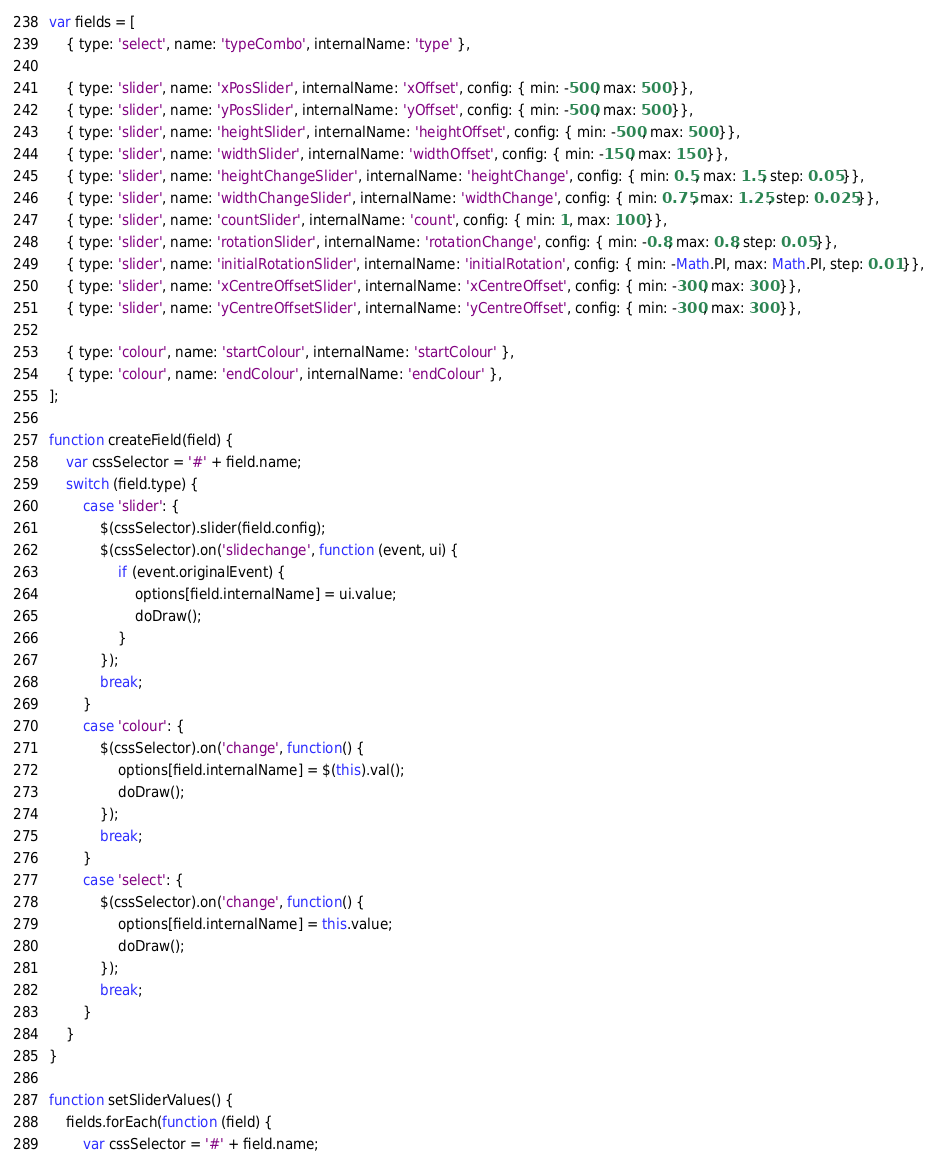Convert code to text. <code><loc_0><loc_0><loc_500><loc_500><_JavaScript_>var fields = [
	{ type: 'select', name: 'typeCombo', internalName: 'type' },

	{ type: 'slider', name: 'xPosSlider', internalName: 'xOffset', config: { min: -500, max: 500 }},
	{ type: 'slider', name: 'yPosSlider', internalName: 'yOffset', config: { min: -500, max: 500 }},
	{ type: 'slider', name: 'heightSlider', internalName: 'heightOffset', config: { min: -500, max: 500 }},
	{ type: 'slider', name: 'widthSlider', internalName: 'widthOffset', config: { min: -150, max: 150 }},
	{ type: 'slider', name: 'heightChangeSlider', internalName: 'heightChange', config: { min: 0.5, max: 1.5, step: 0.05 }},
	{ type: 'slider', name: 'widthChangeSlider', internalName: 'widthChange', config: { min: 0.75, max: 1.25, step: 0.025 }},
	{ type: 'slider', name: 'countSlider', internalName: 'count', config: { min: 1, max: 100 }},
	{ type: 'slider', name: 'rotationSlider', internalName: 'rotationChange', config: { min: -0.8, max: 0.8, step: 0.05 }},
	{ type: 'slider', name: 'initialRotationSlider', internalName: 'initialRotation', config: { min: -Math.PI, max: Math.PI, step: 0.01 }},
	{ type: 'slider', name: 'xCentreOffsetSlider', internalName: 'xCentreOffset', config: { min: -300, max: 300 }},
	{ type: 'slider', name: 'yCentreOffsetSlider', internalName: 'yCentreOffset', config: { min: -300, max: 300 }},

	{ type: 'colour', name: 'startColour', internalName: 'startColour' },
	{ type: 'colour', name: 'endColour', internalName: 'endColour' },
];

function createField(field) {
	var cssSelector = '#' + field.name;
	switch (field.type) {
		case 'slider': {
			$(cssSelector).slider(field.config);
			$(cssSelector).on('slidechange', function (event, ui) {
				if (event.originalEvent) {
					options[field.internalName] = ui.value;
					doDraw();
				}
			});
			break;
		}
		case 'colour': {
			$(cssSelector).on('change', function() {
				options[field.internalName] = $(this).val();
				doDraw();
			});
			break;
		}
		case 'select': {
			$(cssSelector).on('change', function() {
				options[field.internalName] = this.value;
				doDraw();
			});
			break;
		}
	}
}

function setSliderValues() {
	fields.forEach(function (field) {
		var cssSelector = '#' + field.name;</code> 